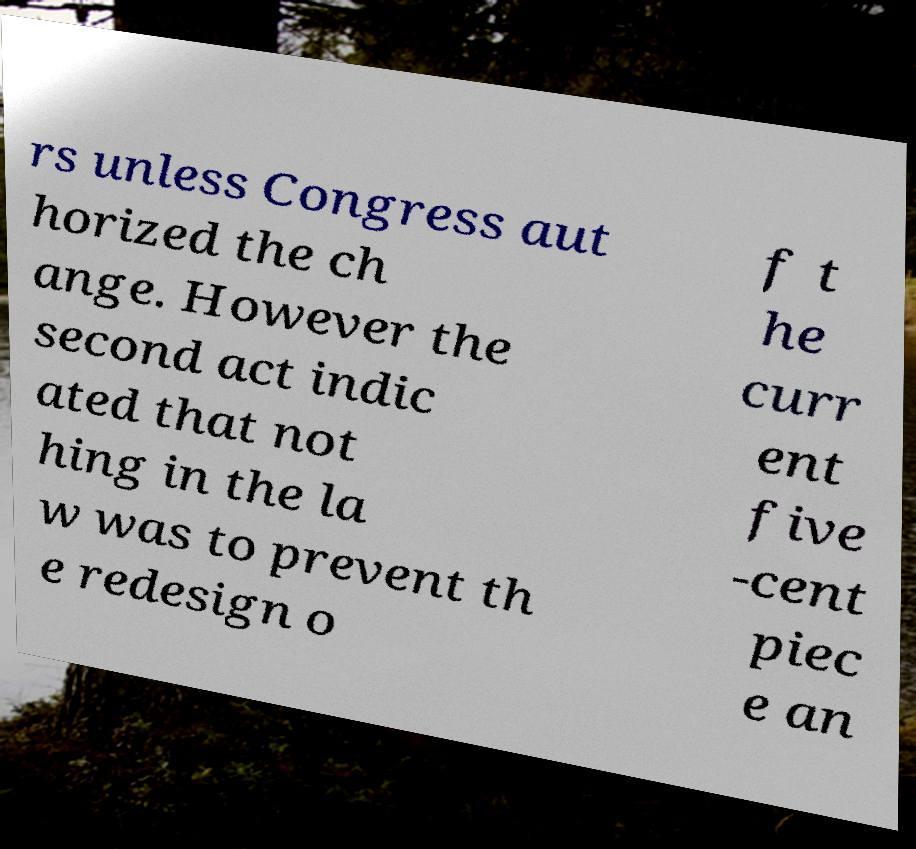For documentation purposes, I need the text within this image transcribed. Could you provide that? rs unless Congress aut horized the ch ange. However the second act indic ated that not hing in the la w was to prevent th e redesign o f t he curr ent five -cent piec e an 